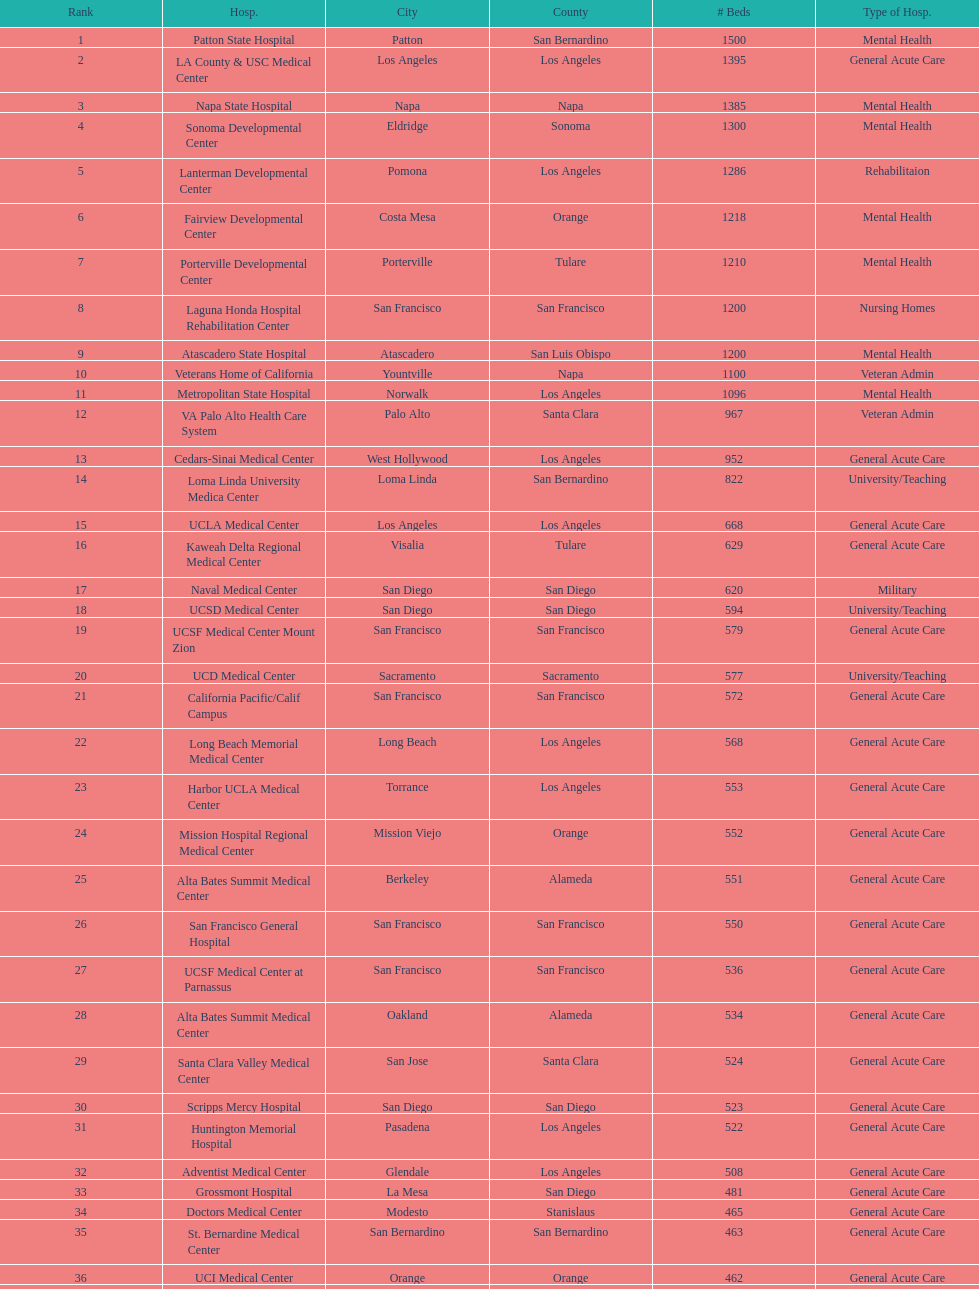How much larger (in number of beds) was the largest hospital in california than the 50th largest? 1071. 